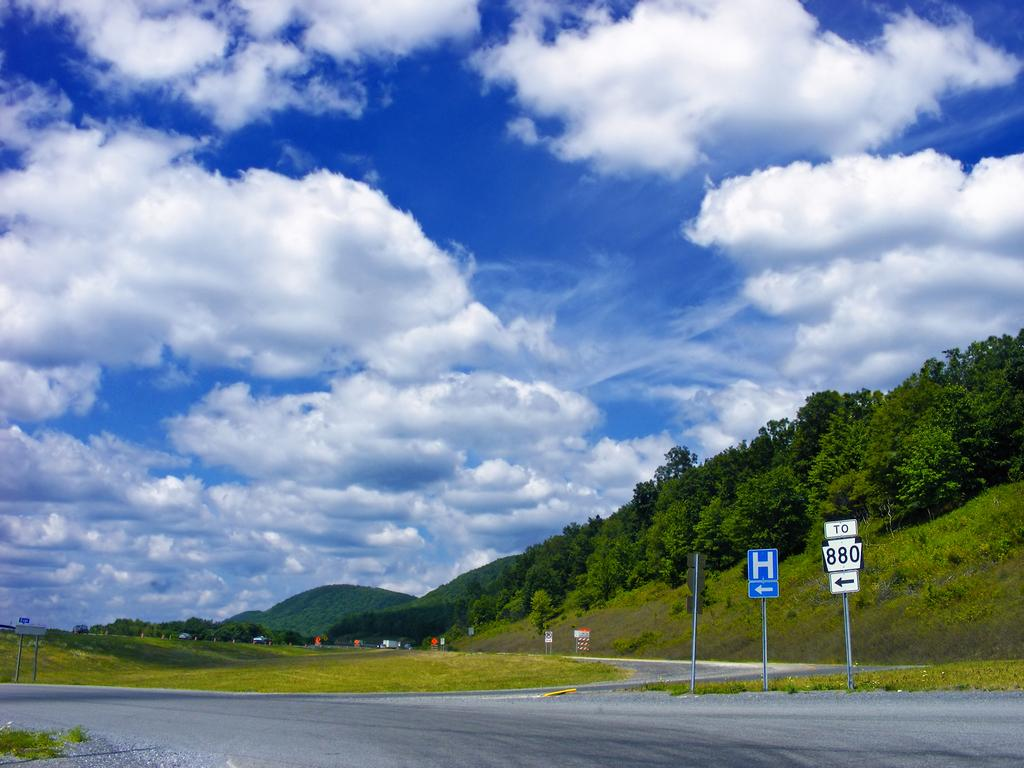What is the main feature of the image? There is a road in the image. What else can be seen along the road? There are sign boards visible in the image. What type of vegetation is present in the image? There is grass visible in the image, and trees are present on the hills. What is the condition of the sky in the image? The sky is cloudy in the image. Can you see any playing cards on the road in the image? There are no playing cards present in the image. Are there any planes flying over the hills in the image? There is no mention of planes in the image; it only features a road, sign boards, grass, hills, trees, and a cloudy sky. 